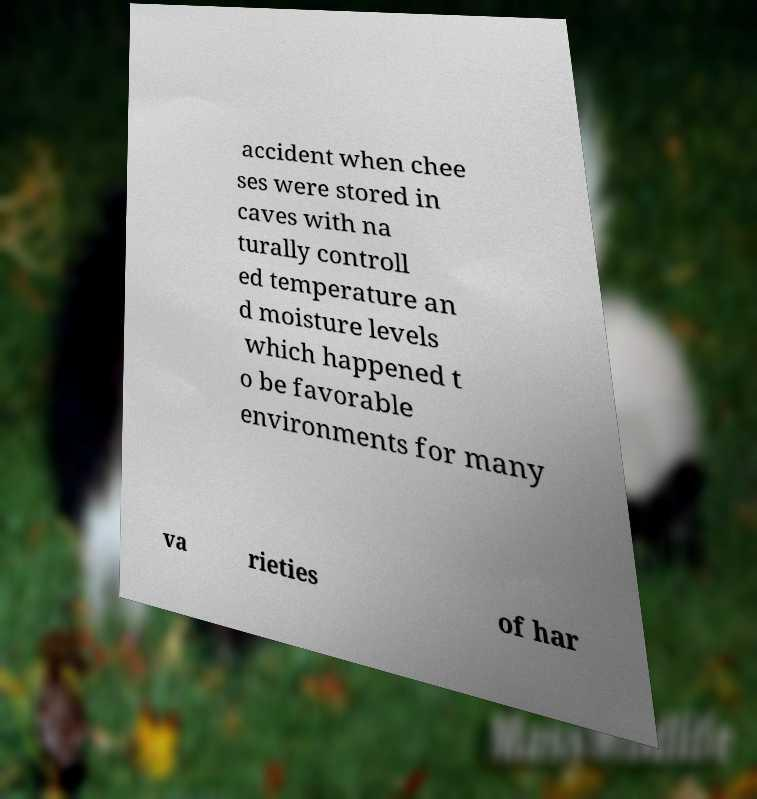Can you accurately transcribe the text from the provided image for me? accident when chee ses were stored in caves with na turally controll ed temperature an d moisture levels which happened t o be favorable environments for many va rieties of har 